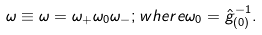Convert formula to latex. <formula><loc_0><loc_0><loc_500><loc_500>\omega \equiv \omega = \omega _ { + } \omega _ { 0 } \omega _ { - } ; w h e r e \omega _ { 0 } = \hat { g } _ { ( 0 ) } ^ { - 1 } .</formula> 